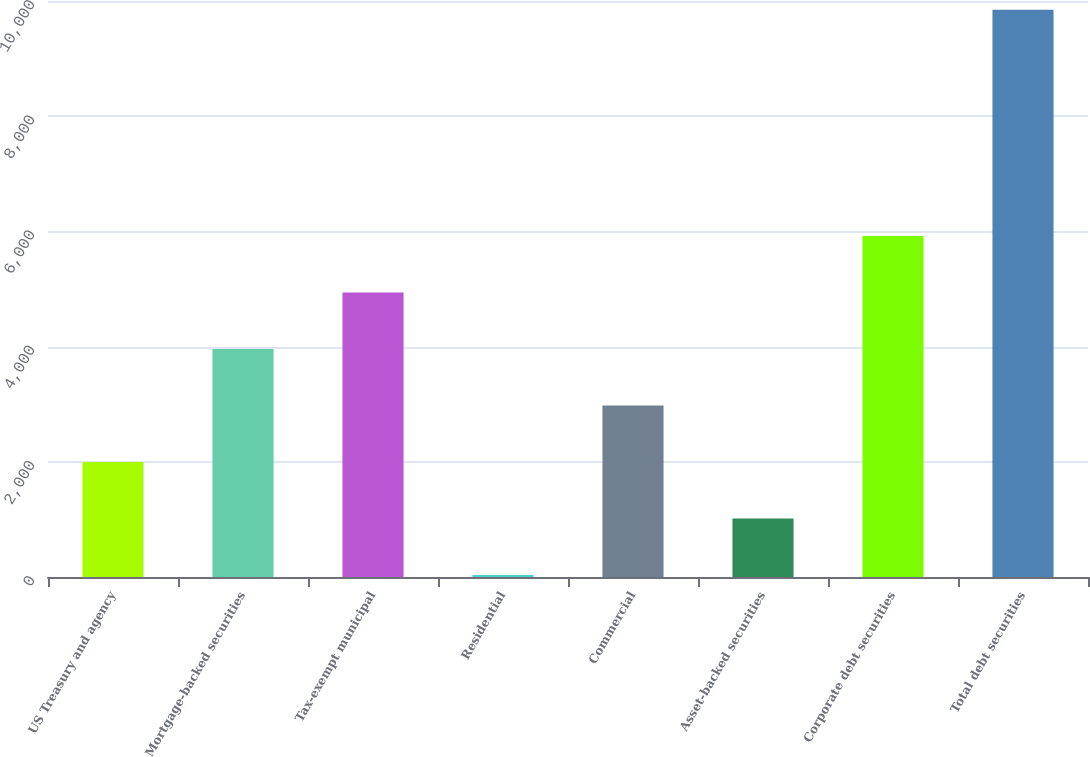<chart> <loc_0><loc_0><loc_500><loc_500><bar_chart><fcel>US Treasury and agency<fcel>Mortgage-backed securities<fcel>Tax-exempt municipal<fcel>Residential<fcel>Commercial<fcel>Asset-backed securities<fcel>Corporate debt securities<fcel>Total debt securities<nl><fcel>1996.6<fcel>3959.2<fcel>4940.5<fcel>34<fcel>2977.9<fcel>1015.3<fcel>5921.8<fcel>9847<nl></chart> 